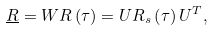Convert formula to latex. <formula><loc_0><loc_0><loc_500><loc_500>\underline { R } = W R \left ( \tau \right ) = U R _ { s } \left ( \tau \right ) U ^ { T } ,</formula> 